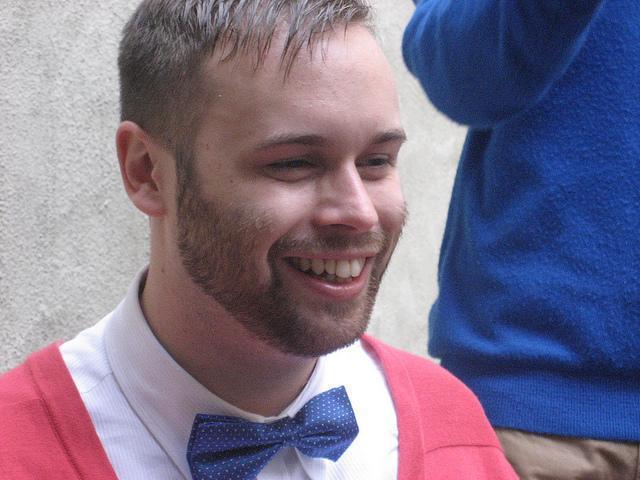How many people are in the picture?
Give a very brief answer. 2. 